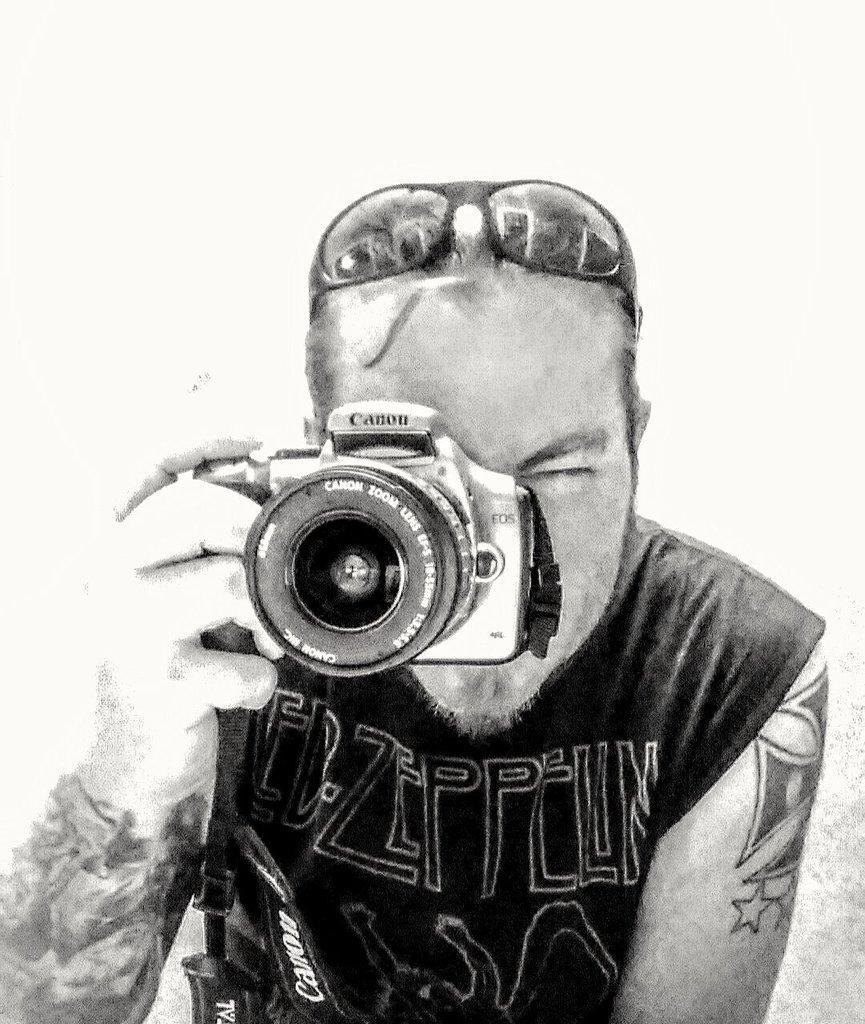Describe this image in one or two sentences. In this picture we can see man wore goggles holding camera in his hand and taking picture. 